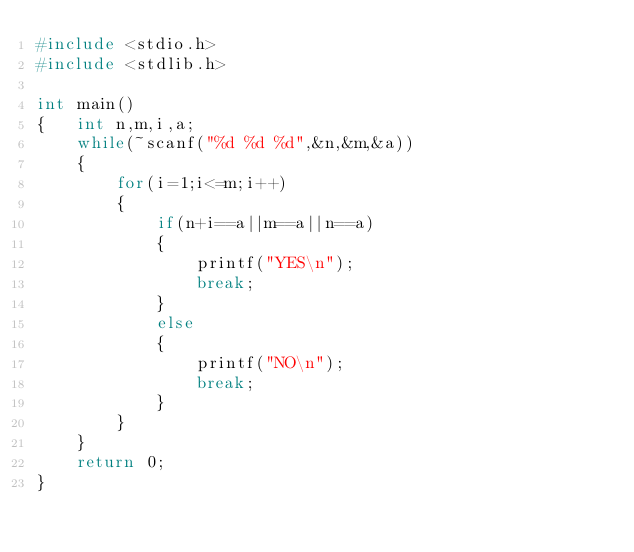<code> <loc_0><loc_0><loc_500><loc_500><_C_>#include <stdio.h>
#include <stdlib.h>

int main()
{   int n,m,i,a;
    while(~scanf("%d %d %d",&n,&m,&a))
    {
        for(i=1;i<=m;i++)
        {
            if(n+i==a||m==a||n==a)
            {
                printf("YES\n");
                break;
            }
            else
            {
                printf("NO\n");
                break;
            }
        }
    }
    return 0;
}
</code> 